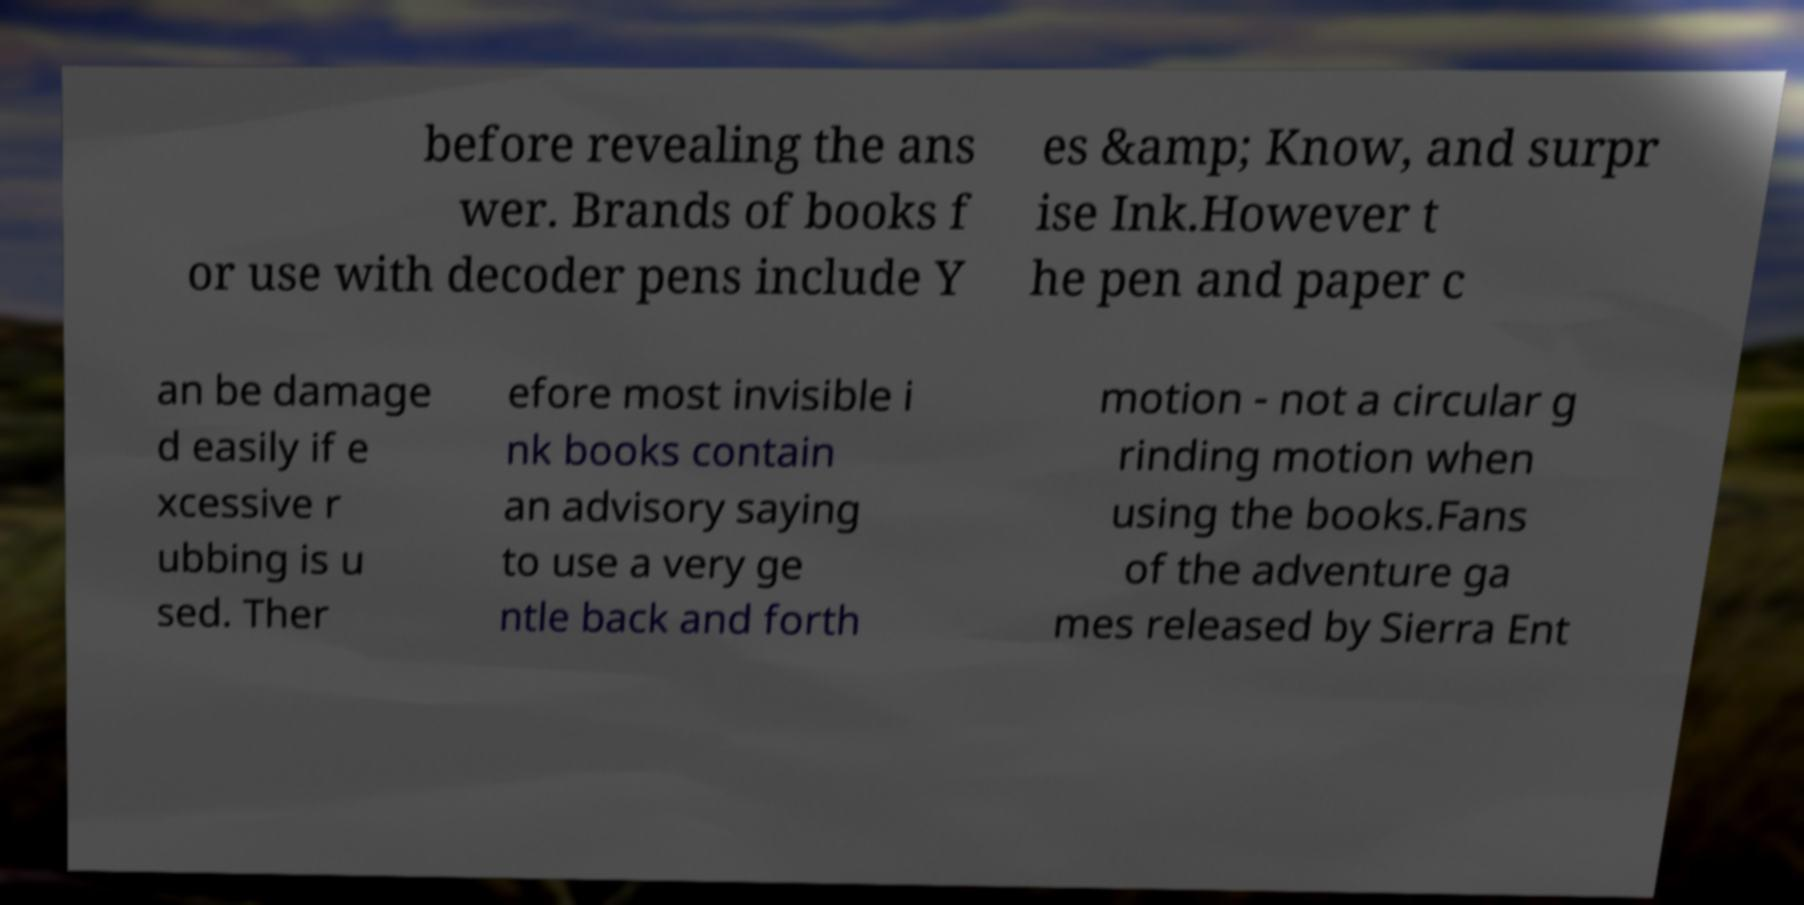Please identify and transcribe the text found in this image. before revealing the ans wer. Brands of books f or use with decoder pens include Y es &amp; Know, and surpr ise Ink.However t he pen and paper c an be damage d easily if e xcessive r ubbing is u sed. Ther efore most invisible i nk books contain an advisory saying to use a very ge ntle back and forth motion - not a circular g rinding motion when using the books.Fans of the adventure ga mes released by Sierra Ent 